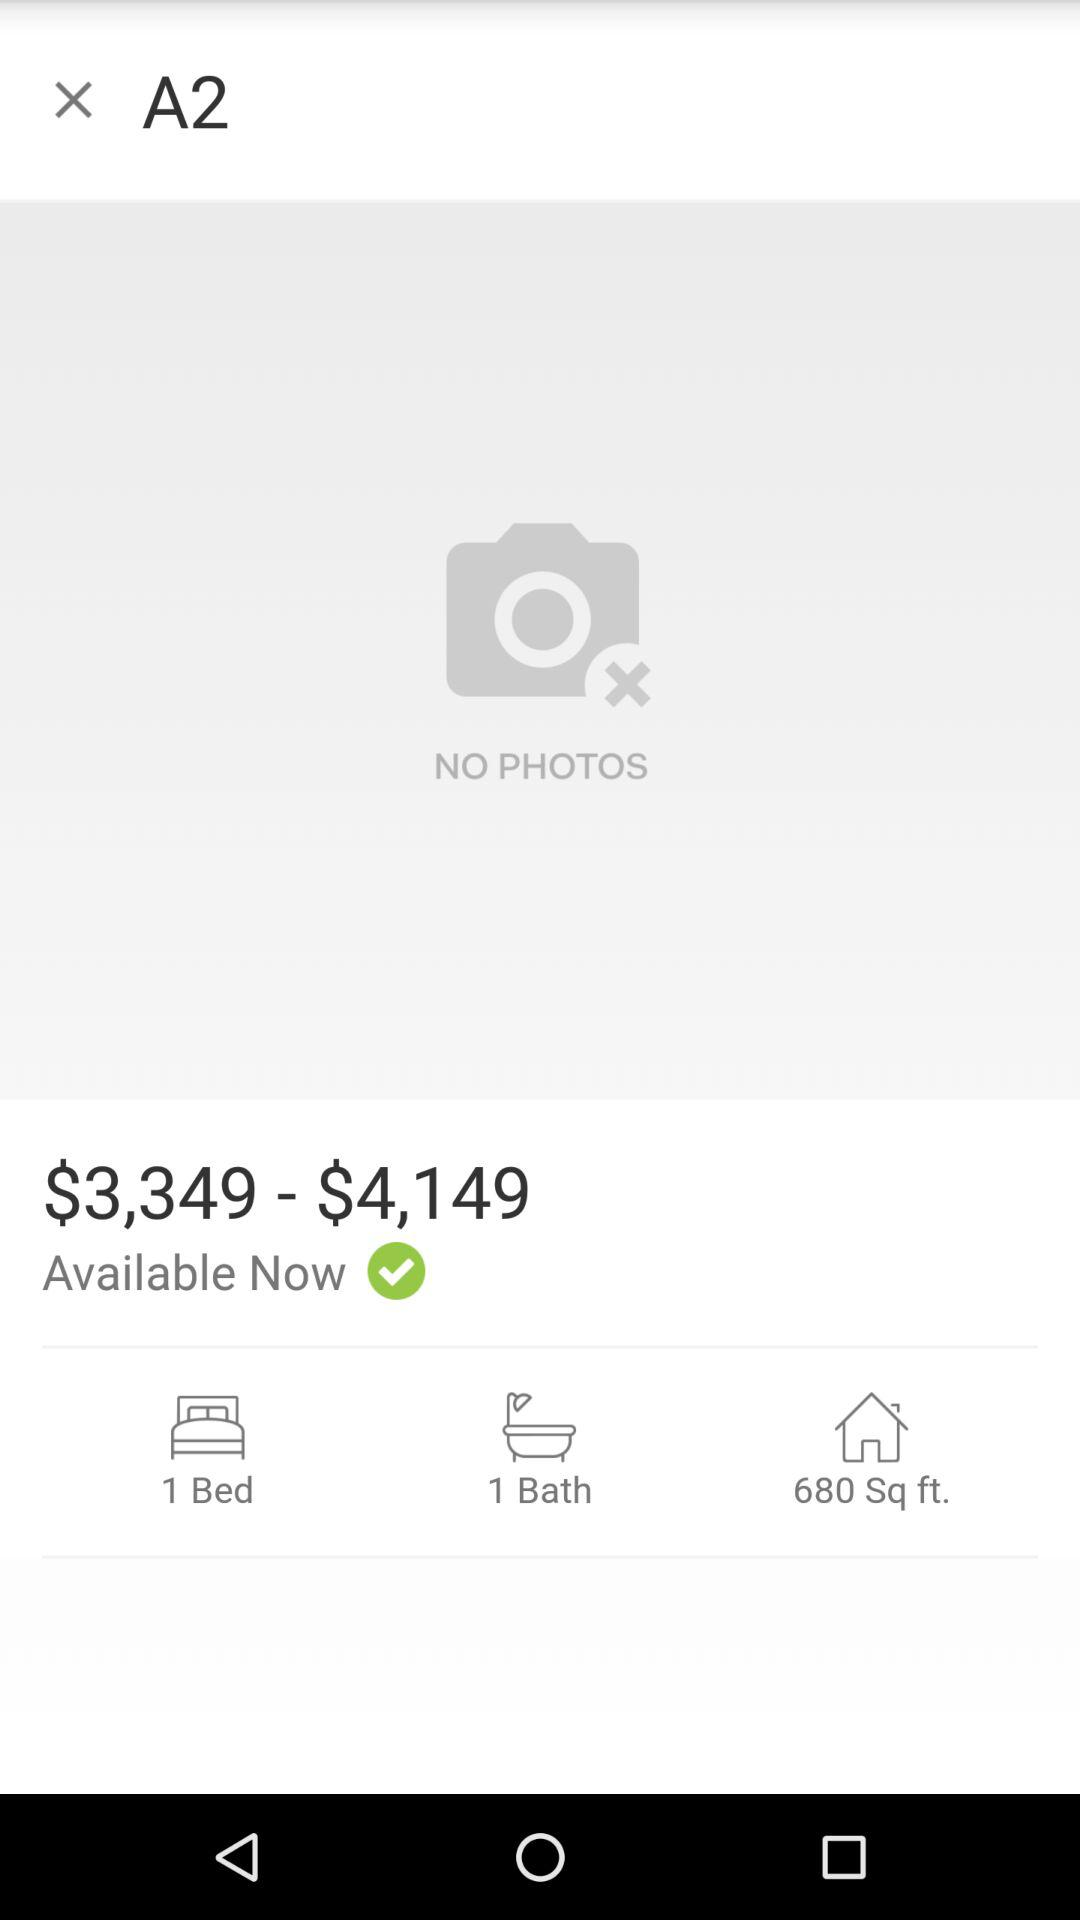What is the area of the house? The area of the house is 680 sq ft. 